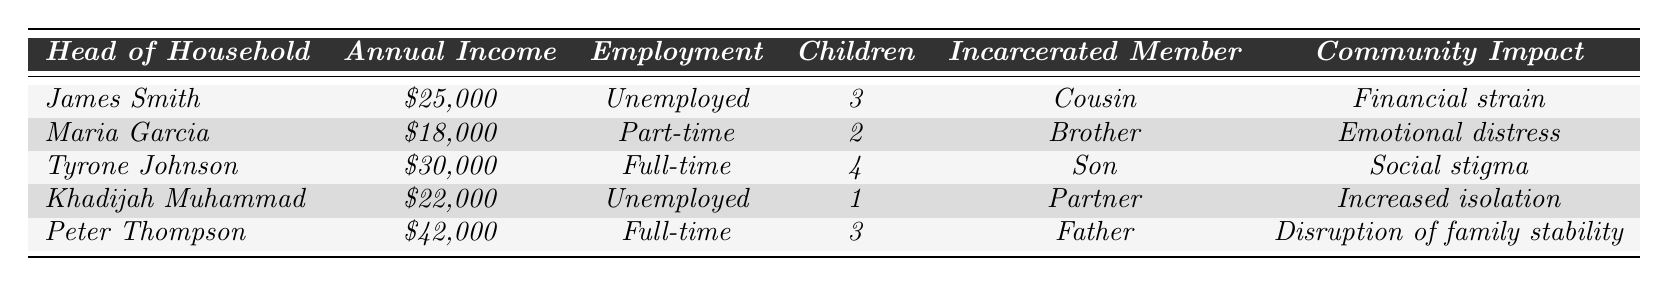What is the annual income of Maria Garcia? The table lists Maria Garcia's annual income in the respective row where her name appears, which is $18,000.
Answer: $18,000 How many children does Peter Thompson have? Looking at the row for Peter Thompson, the number of children is directly stated as 3.
Answer: 3 Is Tyrone Johnson employed full-time? The table indicates that Tyrone Johnson has the employment status of "Full-time," confirming that he is employed full-time.
Answer: Yes Which family has the highest annual income? By comparing the annual incomes listed for each family, Peter Thompson has the highest income at $42,000, while the others are below this value.
Answer: Peter Thompson What is the average annual income of the families? The annual incomes are $25,000, $18,000, $30,000, $22,000, and $42,000. Summing them gives 25,000 + 18,000 + 30,000 + 22,000 + 42,000 = 137,000. Dividing by 5 (number of families) gives an average of 137,000 / 5 = 27,400.
Answer: $27,400 How many families are renting their homes? The table shows that James Smith and Khadijah Muhammad are both renting, totaling 2 families renting.
Answer: 2 What community impact is associated with Khadijah Muhammad's case? The table specifies that for Khadijah Muhammad, the community impact is labeled as "Increased isolation."
Answer: Increased isolation Is there a family with an unemployed head of household, and if so, how many children do they have? Yes, both James Smith and Khadijah Muhammad are unemployed, with their respective children being 3 and 1. This indicates there are two families with unemployed heads of household.
Answer: 3 and 1 Which family affected by incarceration has the youngest head of household? Examining the names alone does not provide age, but by context, we can summarize that younger family heads (such as Maria Garcia and Khadijah Muhammad) might infer lower age, comparing them appears Maria Garcia is the younger when relating to familial roles, though ages aren't directly listed.
Answer: Maria Garcia What is the employment status of the head of household with the longest length of incarceration? The longest length of incarceration listed is 5 years for Maria Garcia's brother, and she is employed part-time according to the data.
Answer: Part-time What is the total number of children in families with an employed head of household? The families with employed heads of household are Tyrone Johnson (4 children) and Peter Thompson (3 children), which sums up to 4 + 3 = 7 children.
Answer: 7 